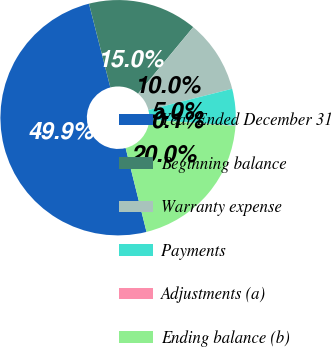Convert chart. <chart><loc_0><loc_0><loc_500><loc_500><pie_chart><fcel>Year Ended December 31<fcel>Beginning balance<fcel>Warranty expense<fcel>Payments<fcel>Adjustments (a)<fcel>Ending balance (b)<nl><fcel>49.9%<fcel>15.0%<fcel>10.02%<fcel>5.03%<fcel>0.05%<fcel>19.99%<nl></chart> 